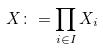Convert formula to latex. <formula><loc_0><loc_0><loc_500><loc_500>X \colon = \prod _ { i \in I } X _ { i }</formula> 